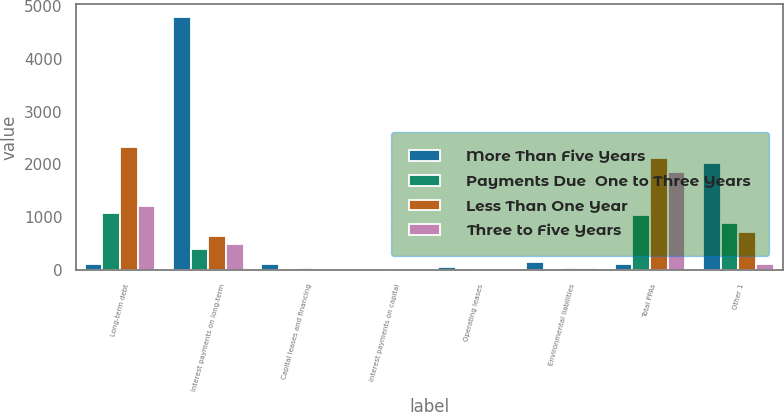<chart> <loc_0><loc_0><loc_500><loc_500><stacked_bar_chart><ecel><fcel>Long-term debt<fcel>Interest payments on long-term<fcel>Capital leases and financing<fcel>Interest payments on capital<fcel>Operating leases<fcel>Environmental liabilities<fcel>Total PPAs<fcel>Other 1<nl><fcel>More Than Five Years<fcel>115<fcel>4785<fcel>113<fcel>32<fcel>53<fcel>157<fcel>115<fcel>2026<nl><fcel>Payments Due  One to Three Years<fcel>1081<fcel>400<fcel>24<fcel>7<fcel>15<fcel>22<fcel>1042<fcel>891<nl><fcel>Less Than One Year<fcel>2333<fcel>639<fcel>44<fcel>12<fcel>18<fcel>36<fcel>2112<fcel>727<nl><fcel>Three to Five Years<fcel>1217<fcel>499<fcel>29<fcel>8<fcel>13<fcel>33<fcel>1858<fcel>117<nl></chart> 